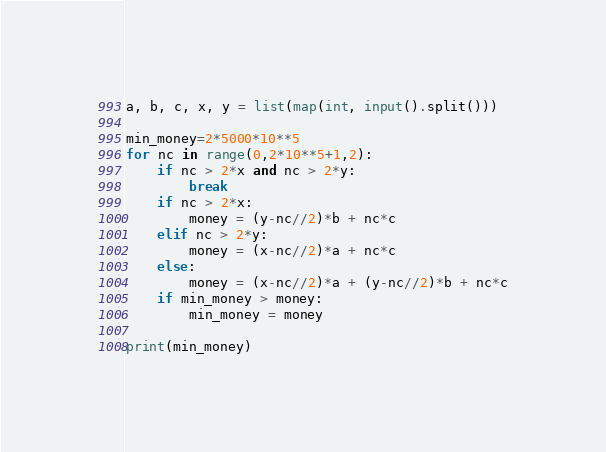<code> <loc_0><loc_0><loc_500><loc_500><_Python_>a, b, c, x, y = list(map(int, input().split()))

min_money=2*5000*10**5
for nc in range(0,2*10**5+1,2):
    if nc > 2*x and nc > 2*y:
        break
    if nc > 2*x:
        money = (y-nc//2)*b + nc*c
    elif nc > 2*y:
        money = (x-nc//2)*a + nc*c
    else:
        money = (x-nc//2)*a + (y-nc//2)*b + nc*c
    if min_money > money:
        min_money = money
            
print(min_money)</code> 